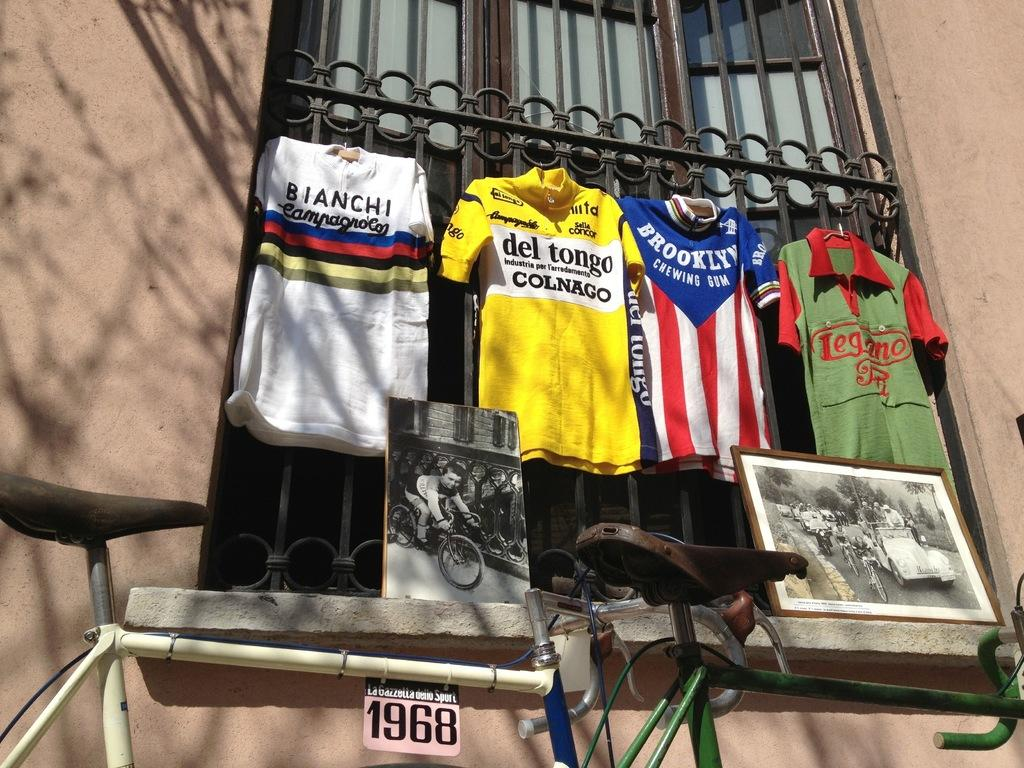<image>
Describe the image concisely. some shirts with one that says 1968 on it 